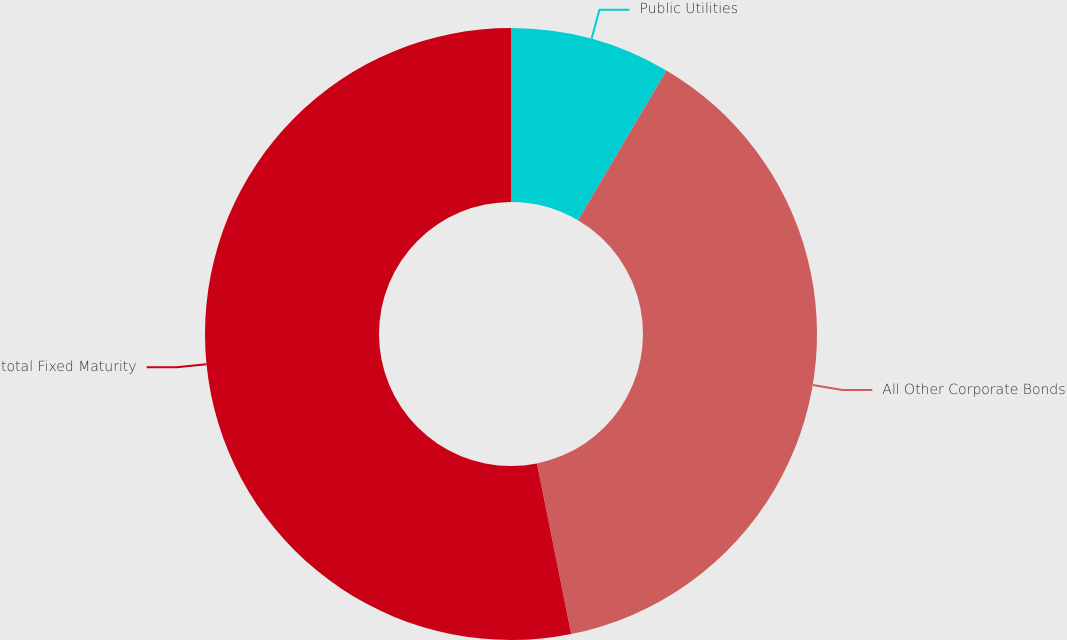Convert chart. <chart><loc_0><loc_0><loc_500><loc_500><pie_chart><fcel>Public Utilities<fcel>All Other Corporate Bonds<fcel>total Fixed Maturity<nl><fcel>8.48%<fcel>38.37%<fcel>53.15%<nl></chart> 